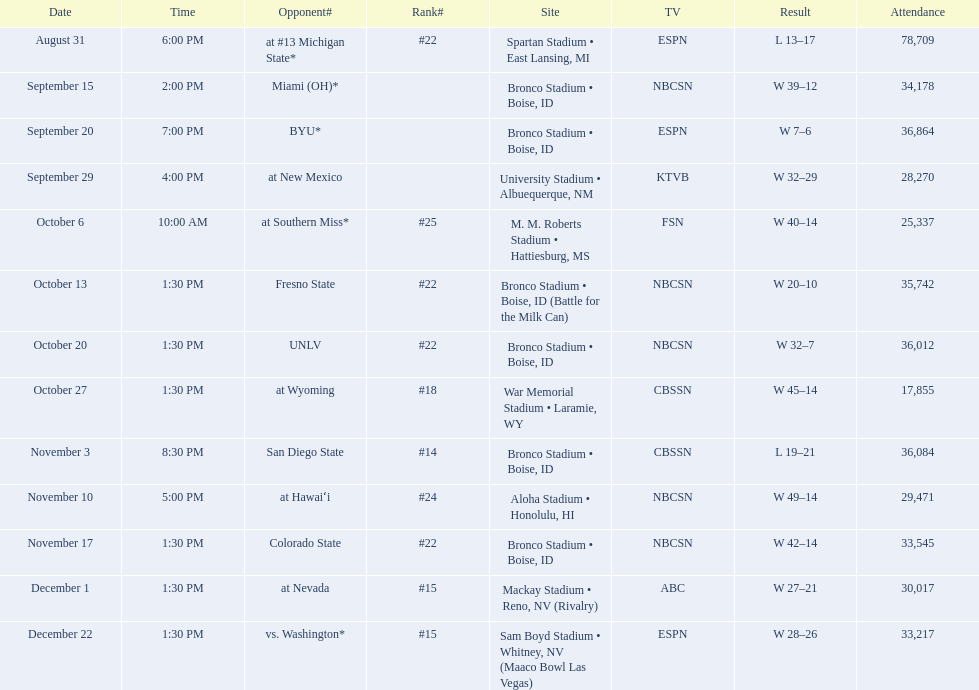Who were all the teams that faced boise state? At #13 michigan state*, miami (oh)*, byu*, at new mexico, at southern miss*, fresno state, unlv, at wyoming, san diego state, at hawaiʻi, colorado state, at nevada, vs. washington*. Which of these teams were ranked? At #13 michigan state*, #22, at southern miss*, #25, fresno state, #22, unlv, #22, at wyoming, #18, san diego state, #14. Which team held the highest ranking? San Diego State. 